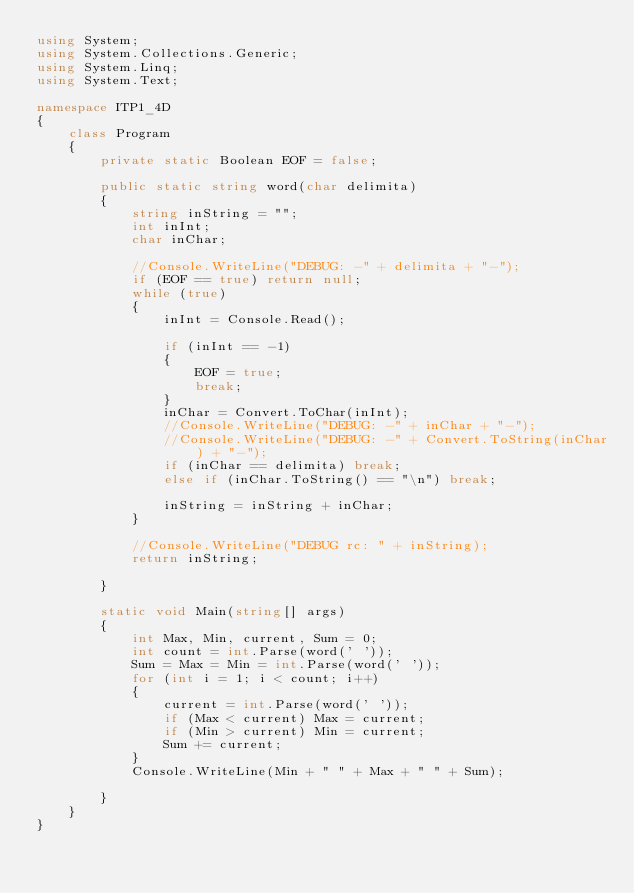Convert code to text. <code><loc_0><loc_0><loc_500><loc_500><_C#_>using System;
using System.Collections.Generic;
using System.Linq;
using System.Text;

namespace ITP1_4D
{
    class Program
    {
        private static Boolean EOF = false;

        public static string word(char delimita)
        {
            string inString = "";
            int inInt;
            char inChar;

            //Console.WriteLine("DEBUG: -" + delimita + "-");
            if (EOF == true) return null;
            while (true)
            {
                inInt = Console.Read();
                
                if (inInt == -1)
                {
                    EOF = true;
                    break;
                }
                inChar = Convert.ToChar(inInt);
                //Console.WriteLine("DEBUG: -" + inChar + "-");
                //Console.WriteLine("DEBUG: -" + Convert.ToString(inChar) + "-");
                if (inChar == delimita) break;
                else if (inChar.ToString() == "\n") break;

                inString = inString + inChar;
            }

            //Console.WriteLine("DEBUG rc: " + inString);
            return inString;

        }

        static void Main(string[] args)
        {
            int Max, Min, current, Sum = 0;
            int count = int.Parse(word(' '));
            Sum = Max = Min = int.Parse(word(' '));
            for (int i = 1; i < count; i++)
            {
                current = int.Parse(word(' '));
                if (Max < current) Max = current;
                if (Min > current) Min = current;
                Sum += current;
            }
            Console.WriteLine(Min + " " + Max + " " + Sum);

        }
    }
}</code> 